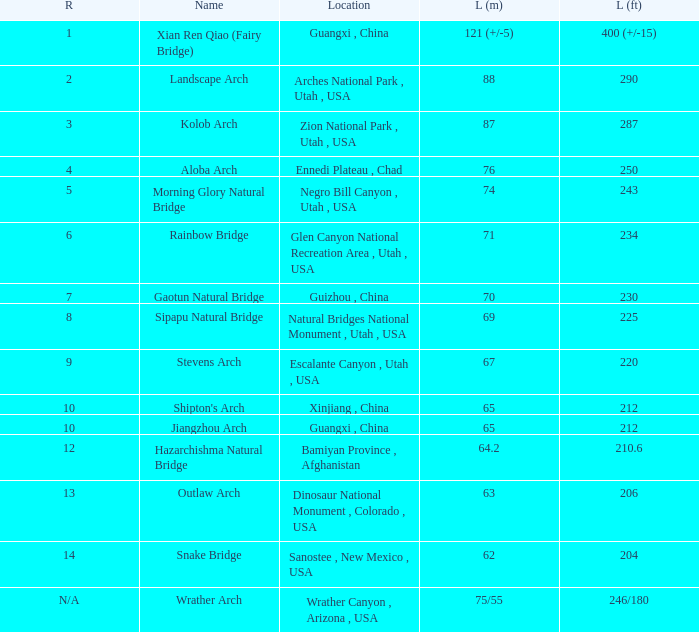What is the rank of the arch with a length in meters of 75/55? N/A. 